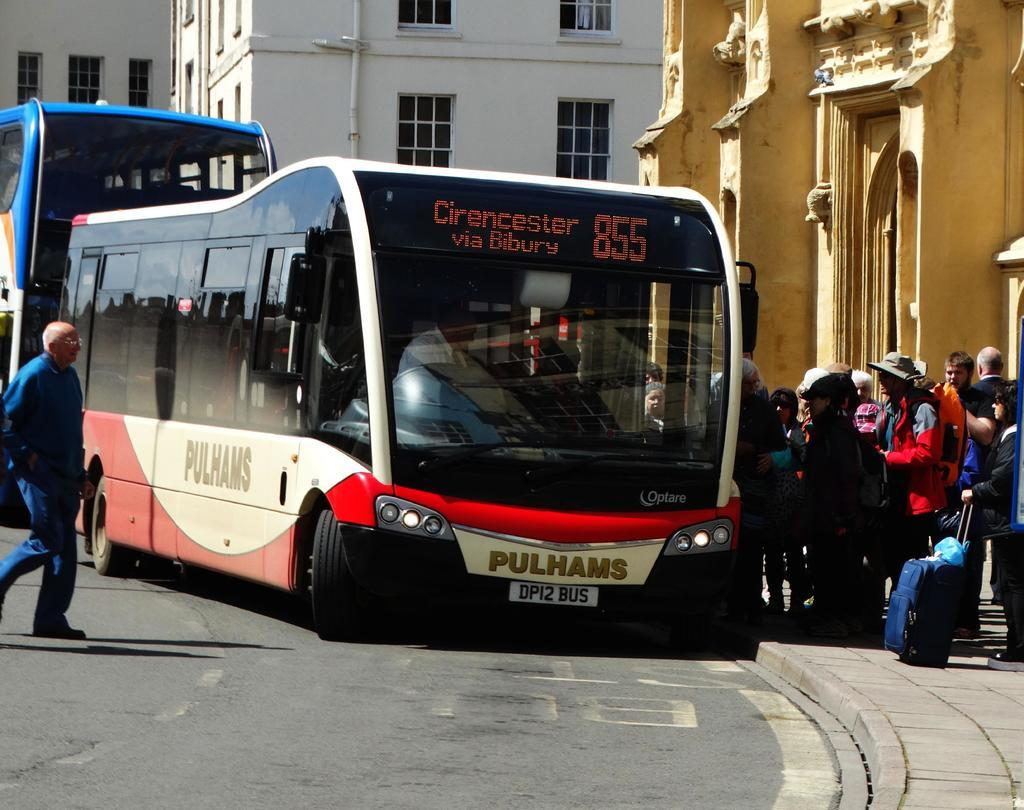What is the main subject in the center of the image? There is a bus in the center of the image. Where is the bus located? The bus is on the road. What can be seen on the right side of the image? There are people on the footpath on the right side of the image. What is visible in the background of the image? There are buildings visible in the background of the image. How many cherries are on the bus in the image? There are no cherries present in the image, as it features a bus on the road with people on the footpath and buildings in the background. 